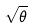Convert formula to latex. <formula><loc_0><loc_0><loc_500><loc_500>\sqrt { \theta }</formula> 